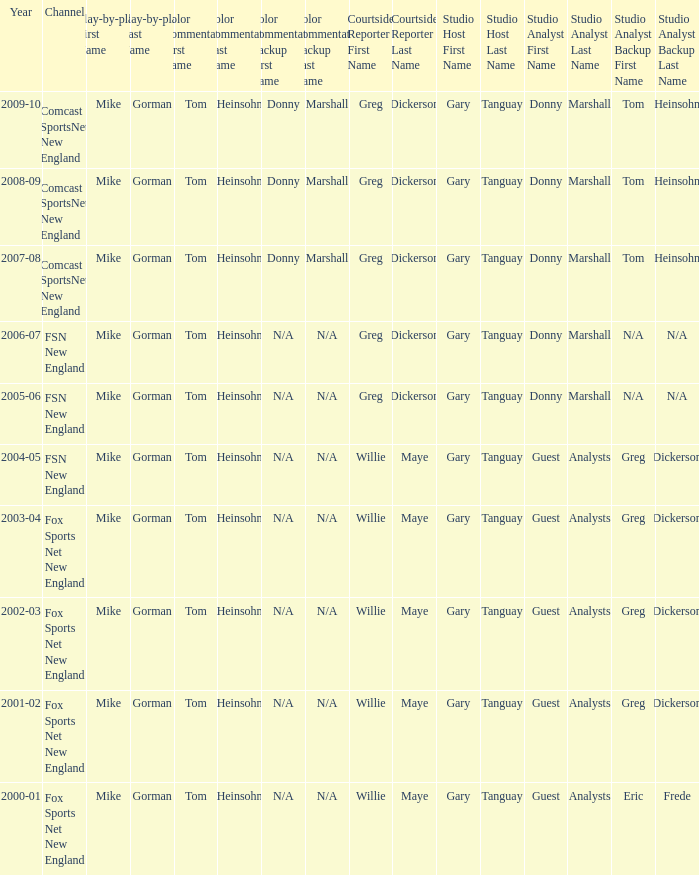WHich Play-by-play has a Studio host of gary tanguay, and a Studio analysts of donny marshall? Mike Gorman, Mike Gorman. 